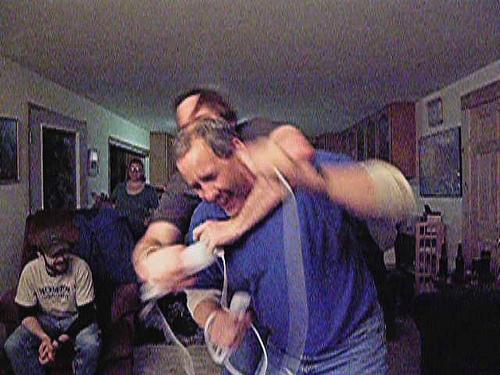How many people are visible?
Give a very brief answer. 5. How many dogs are shown?
Give a very brief answer. 0. 